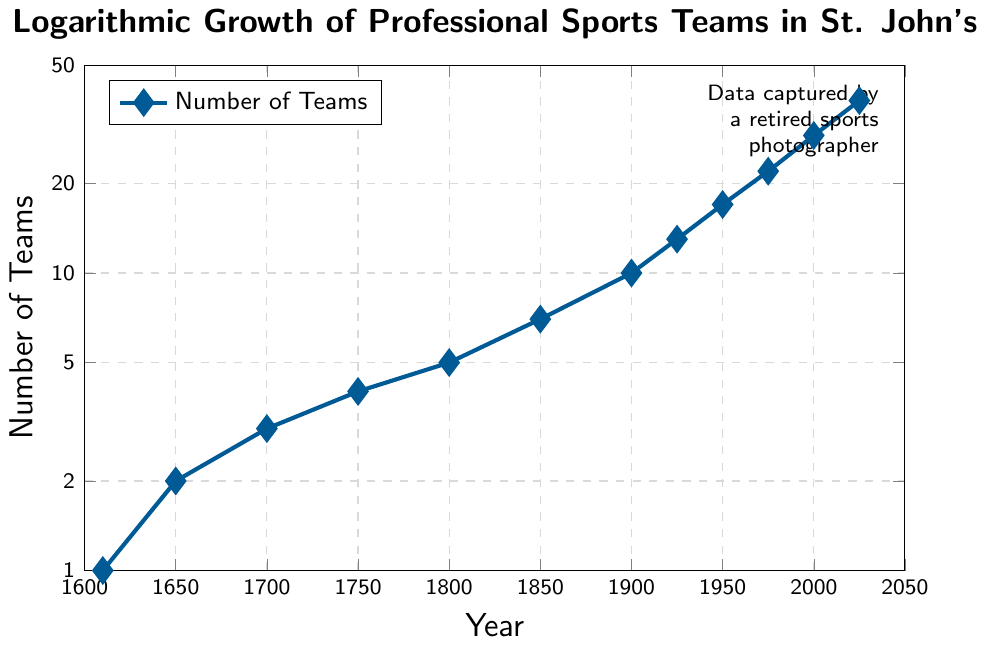1. How many professional sports teams were there in St. John's in 1850? Referring to the year 1850 on the x-axis and the corresponding y-coordinate, we see that there were 7 professional sports teams.
Answer: 7 2. Between which two consecutive periods was the largest increase in the number of professional sports teams? By comparing the differences between all consecutive periods, the largest increase is from 2000 to 2025 with a jump from 29 to 38.
Answer: 2000 to 2025 3. What is the average number of professional sports teams from 1600 to 1800? The data points from 1610 to 1800 are 1, 2, 3, 4, and 5. Their sum is 1 + 2 + 3 + 4 + 5 = 15, and there are 5 data points, so the average is 15/5.
Answer: 3 4. What is the ratio of the number of professional sports teams in 2000 compared to 1925? In 2000, there are 29 teams and in 1925, there are 13 teams. The ratio is 29/13.
Answer: 29/13 5. Did the number of professional sports teams ever double in less than 50 years? From 1900 to 1950, the number of teams increased from 10 to 17, which is not a doubling. From 1950 to 2000, 17 doubled would be 34, but the increase was to 29, which is not doubling. Thus, no period resulted in a doubling in less than 50 years.
Answer: No 6. What is the logarithmic scale used on the y-axis? The y-axis ticks are marked by powers of 10: 1, 2, 5, 10, 20, 50 indicating a logarithmic scale in base 10.
Answer: Base 10 7. What is the growth trend of the number of professional sports teams from 1700 to 1975? The teams increased from 3 in 1700 to 22 in 1975, showing a consistent logarithmic growth pattern over these years.
Answer: Consistent logarithmic growth 8. Approximately how many professional sports teams were added between 1925 and 2025? The number of teams increased from 13 in 1925 to 38 in 2025. Subtracting these values gives 38 - 13.
Answer: 25 9. How does the growth from 1750 to 1850 compare to the growth from 1900 to 2000? From 1750 to 1850, the number increased from 4 to 7, which is an increase of 3. From 1900 to 2000, the increase was from 10 to 29, a rise of 19.
Answer: Growth from 1900 to 2000 is greater 10. What is the color of the line representing the number of teams? The line representing the number of teams is a shade of blue, which is visually distinguishable in the plot.
Answer: Blue 